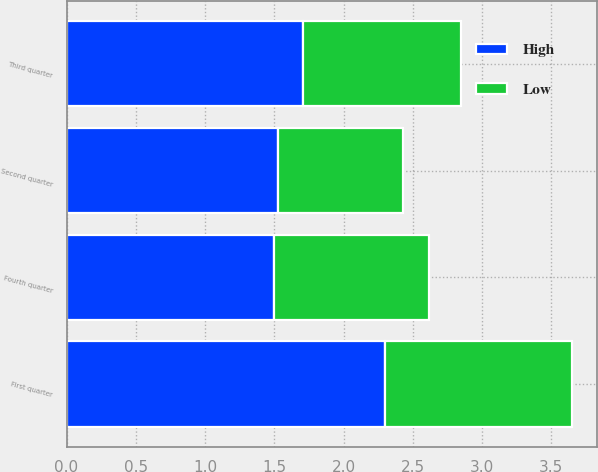Convert chart to OTSL. <chart><loc_0><loc_0><loc_500><loc_500><stacked_bar_chart><ecel><fcel>First quarter<fcel>Second quarter<fcel>Third quarter<fcel>Fourth quarter<nl><fcel>High<fcel>2.3<fcel>1.53<fcel>1.71<fcel>1.5<nl><fcel>Low<fcel>1.35<fcel>0.9<fcel>1.14<fcel>1.12<nl></chart> 